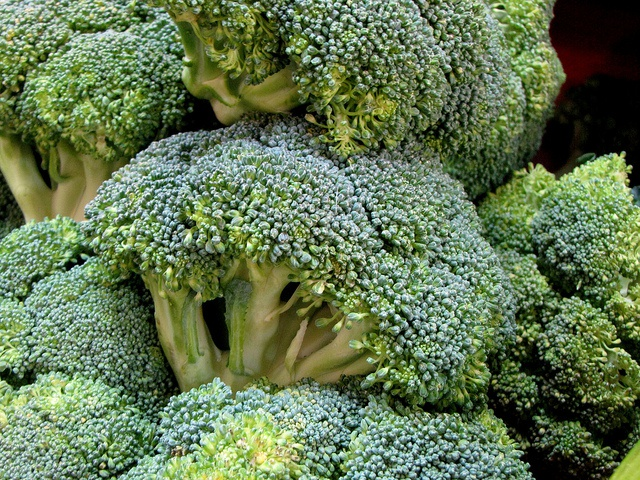Describe the objects in this image and their specific colors. I can see a broccoli in lightgray, darkgreen, black, gray, and darkgray tones in this image. 